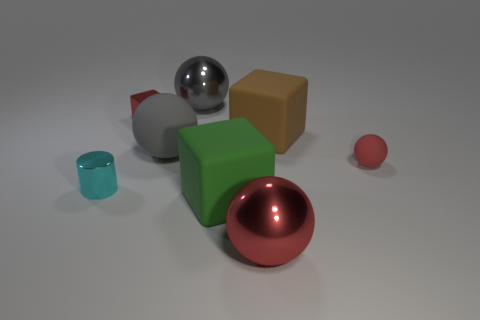The other sphere that is the same color as the small rubber sphere is what size?
Offer a terse response. Large. What material is the tiny object that is the same shape as the big red metal object?
Your answer should be very brief. Rubber. What is the material of the cube that is both right of the gray rubber sphere and behind the large gray rubber object?
Your answer should be compact. Rubber. How many brown objects are shiny cubes or cylinders?
Offer a very short reply. 0. There is a big metallic object behind the big red ball; what number of large brown matte things are behind it?
Keep it short and to the point. 0. Are there any other things of the same color as the tiny shiny block?
Your answer should be very brief. Yes. What is the shape of the red object that is the same material as the brown object?
Make the answer very short. Sphere. Is the color of the small metal block the same as the tiny ball?
Give a very brief answer. Yes. Does the large red sphere in front of the cyan cylinder have the same material as the cube that is behind the big brown rubber block?
Your answer should be very brief. Yes. What number of things are green rubber cubes or matte objects that are left of the big gray metal object?
Your answer should be compact. 2. 